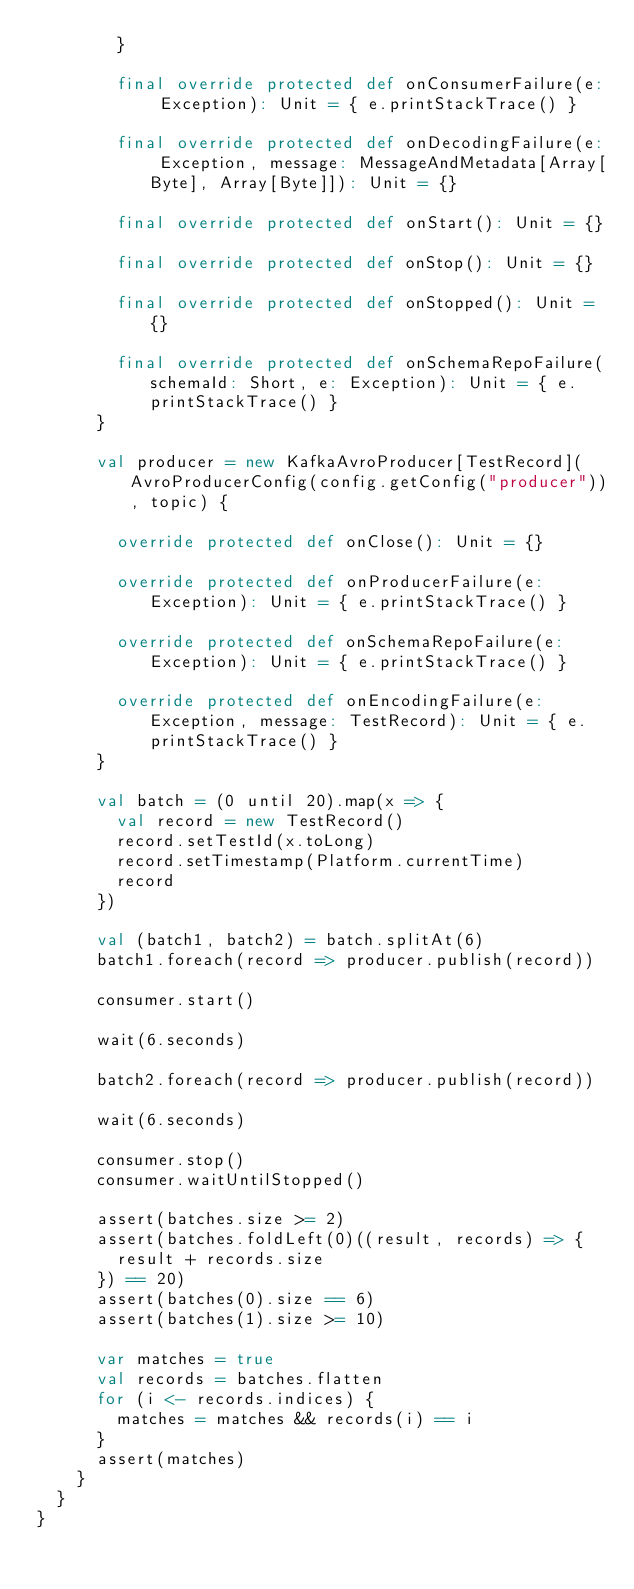Convert code to text. <code><loc_0><loc_0><loc_500><loc_500><_Scala_>        }

        final override protected def onConsumerFailure(e: Exception): Unit = { e.printStackTrace() }

        final override protected def onDecodingFailure(e: Exception, message: MessageAndMetadata[Array[Byte], Array[Byte]]): Unit = {}

        final override protected def onStart(): Unit = {}

        final override protected def onStop(): Unit = {}

        final override protected def onStopped(): Unit = {}

        final override protected def onSchemaRepoFailure(schemaId: Short, e: Exception): Unit = { e.printStackTrace() }
      }

      val producer = new KafkaAvroProducer[TestRecord](AvroProducerConfig(config.getConfig("producer")), topic) {

        override protected def onClose(): Unit = {}

        override protected def onProducerFailure(e: Exception): Unit = { e.printStackTrace() }

        override protected def onSchemaRepoFailure(e: Exception): Unit = { e.printStackTrace() }

        override protected def onEncodingFailure(e: Exception, message: TestRecord): Unit = { e.printStackTrace() }
      }

      val batch = (0 until 20).map(x => {
        val record = new TestRecord()
        record.setTestId(x.toLong)
        record.setTimestamp(Platform.currentTime)
        record
      })

      val (batch1, batch2) = batch.splitAt(6)
      batch1.foreach(record => producer.publish(record))

      consumer.start()

      wait(6.seconds)

      batch2.foreach(record => producer.publish(record))

      wait(6.seconds)

      consumer.stop()
      consumer.waitUntilStopped()

      assert(batches.size >= 2)
      assert(batches.foldLeft(0)((result, records) => {
        result + records.size
      }) == 20)
      assert(batches(0).size == 6)
      assert(batches(1).size >= 10)

      var matches = true
      val records = batches.flatten
      for (i <- records.indices) {
        matches = matches && records(i) == i
      }
      assert(matches)
    }
  }
}
</code> 